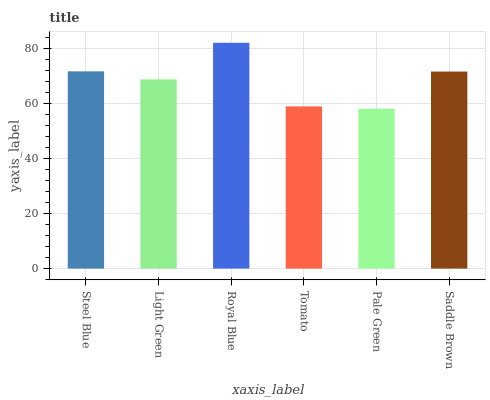Is Pale Green the minimum?
Answer yes or no. Yes. Is Royal Blue the maximum?
Answer yes or no. Yes. Is Light Green the minimum?
Answer yes or no. No. Is Light Green the maximum?
Answer yes or no. No. Is Steel Blue greater than Light Green?
Answer yes or no. Yes. Is Light Green less than Steel Blue?
Answer yes or no. Yes. Is Light Green greater than Steel Blue?
Answer yes or no. No. Is Steel Blue less than Light Green?
Answer yes or no. No. Is Saddle Brown the high median?
Answer yes or no. Yes. Is Light Green the low median?
Answer yes or no. Yes. Is Tomato the high median?
Answer yes or no. No. Is Saddle Brown the low median?
Answer yes or no. No. 